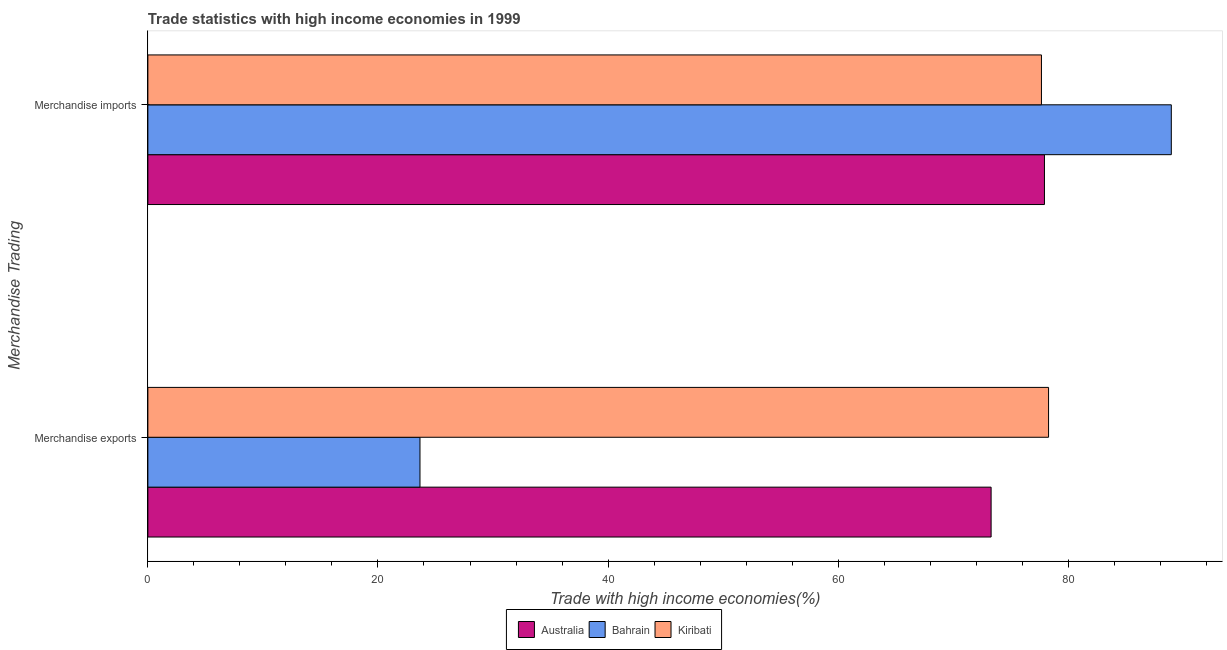How many different coloured bars are there?
Give a very brief answer. 3. Are the number of bars on each tick of the Y-axis equal?
Your response must be concise. Yes. How many bars are there on the 1st tick from the bottom?
Your answer should be very brief. 3. What is the merchandise exports in Kiribati?
Keep it short and to the point. 78.29. Across all countries, what is the maximum merchandise imports?
Ensure brevity in your answer.  88.96. Across all countries, what is the minimum merchandise exports?
Give a very brief answer. 23.65. In which country was the merchandise imports maximum?
Provide a succinct answer. Bahrain. In which country was the merchandise imports minimum?
Your answer should be compact. Kiribati. What is the total merchandise exports in the graph?
Keep it short and to the point. 175.24. What is the difference between the merchandise imports in Kiribati and that in Australia?
Your answer should be compact. -0.26. What is the difference between the merchandise exports in Kiribati and the merchandise imports in Australia?
Give a very brief answer. 0.36. What is the average merchandise exports per country?
Ensure brevity in your answer.  58.41. What is the difference between the merchandise imports and merchandise exports in Australia?
Your response must be concise. 4.64. In how many countries, is the merchandise exports greater than 84 %?
Make the answer very short. 0. What is the ratio of the merchandise imports in Bahrain to that in Kiribati?
Keep it short and to the point. 1.15. Is the merchandise exports in Kiribati less than that in Bahrain?
Your response must be concise. No. In how many countries, is the merchandise exports greater than the average merchandise exports taken over all countries?
Provide a short and direct response. 2. What does the 1st bar from the top in Merchandise exports represents?
Your response must be concise. Kiribati. How many bars are there?
Keep it short and to the point. 6. Are all the bars in the graph horizontal?
Give a very brief answer. Yes. Are the values on the major ticks of X-axis written in scientific E-notation?
Your answer should be very brief. No. Does the graph contain any zero values?
Provide a succinct answer. No. Does the graph contain grids?
Give a very brief answer. No. Where does the legend appear in the graph?
Your response must be concise. Bottom center. How many legend labels are there?
Provide a short and direct response. 3. How are the legend labels stacked?
Make the answer very short. Horizontal. What is the title of the graph?
Offer a very short reply. Trade statistics with high income economies in 1999. Does "Ecuador" appear as one of the legend labels in the graph?
Ensure brevity in your answer.  No. What is the label or title of the X-axis?
Your answer should be very brief. Trade with high income economies(%). What is the label or title of the Y-axis?
Ensure brevity in your answer.  Merchandise Trading. What is the Trade with high income economies(%) in Australia in Merchandise exports?
Your answer should be very brief. 73.29. What is the Trade with high income economies(%) of Bahrain in Merchandise exports?
Your response must be concise. 23.65. What is the Trade with high income economies(%) of Kiribati in Merchandise exports?
Give a very brief answer. 78.29. What is the Trade with high income economies(%) of Australia in Merchandise imports?
Make the answer very short. 77.93. What is the Trade with high income economies(%) in Bahrain in Merchandise imports?
Keep it short and to the point. 88.96. What is the Trade with high income economies(%) of Kiribati in Merchandise imports?
Provide a short and direct response. 77.67. Across all Merchandise Trading, what is the maximum Trade with high income economies(%) in Australia?
Provide a succinct answer. 77.93. Across all Merchandise Trading, what is the maximum Trade with high income economies(%) of Bahrain?
Give a very brief answer. 88.96. Across all Merchandise Trading, what is the maximum Trade with high income economies(%) in Kiribati?
Keep it short and to the point. 78.29. Across all Merchandise Trading, what is the minimum Trade with high income economies(%) of Australia?
Offer a terse response. 73.29. Across all Merchandise Trading, what is the minimum Trade with high income economies(%) in Bahrain?
Offer a very short reply. 23.65. Across all Merchandise Trading, what is the minimum Trade with high income economies(%) of Kiribati?
Provide a short and direct response. 77.67. What is the total Trade with high income economies(%) in Australia in the graph?
Ensure brevity in your answer.  151.23. What is the total Trade with high income economies(%) in Bahrain in the graph?
Your answer should be compact. 112.61. What is the total Trade with high income economies(%) of Kiribati in the graph?
Provide a short and direct response. 155.96. What is the difference between the Trade with high income economies(%) of Australia in Merchandise exports and that in Merchandise imports?
Give a very brief answer. -4.64. What is the difference between the Trade with high income economies(%) of Bahrain in Merchandise exports and that in Merchandise imports?
Offer a terse response. -65.31. What is the difference between the Trade with high income economies(%) of Kiribati in Merchandise exports and that in Merchandise imports?
Make the answer very short. 0.62. What is the difference between the Trade with high income economies(%) in Australia in Merchandise exports and the Trade with high income economies(%) in Bahrain in Merchandise imports?
Make the answer very short. -15.66. What is the difference between the Trade with high income economies(%) of Australia in Merchandise exports and the Trade with high income economies(%) of Kiribati in Merchandise imports?
Offer a very short reply. -4.38. What is the difference between the Trade with high income economies(%) in Bahrain in Merchandise exports and the Trade with high income economies(%) in Kiribati in Merchandise imports?
Offer a terse response. -54.02. What is the average Trade with high income economies(%) in Australia per Merchandise Trading?
Keep it short and to the point. 75.61. What is the average Trade with high income economies(%) of Bahrain per Merchandise Trading?
Provide a succinct answer. 56.31. What is the average Trade with high income economies(%) of Kiribati per Merchandise Trading?
Offer a very short reply. 77.98. What is the difference between the Trade with high income economies(%) of Australia and Trade with high income economies(%) of Bahrain in Merchandise exports?
Your answer should be compact. 49.64. What is the difference between the Trade with high income economies(%) in Australia and Trade with high income economies(%) in Kiribati in Merchandise exports?
Provide a short and direct response. -4.99. What is the difference between the Trade with high income economies(%) in Bahrain and Trade with high income economies(%) in Kiribati in Merchandise exports?
Ensure brevity in your answer.  -54.64. What is the difference between the Trade with high income economies(%) in Australia and Trade with high income economies(%) in Bahrain in Merchandise imports?
Give a very brief answer. -11.03. What is the difference between the Trade with high income economies(%) in Australia and Trade with high income economies(%) in Kiribati in Merchandise imports?
Your answer should be very brief. 0.26. What is the difference between the Trade with high income economies(%) in Bahrain and Trade with high income economies(%) in Kiribati in Merchandise imports?
Provide a short and direct response. 11.29. What is the ratio of the Trade with high income economies(%) in Australia in Merchandise exports to that in Merchandise imports?
Keep it short and to the point. 0.94. What is the ratio of the Trade with high income economies(%) in Bahrain in Merchandise exports to that in Merchandise imports?
Keep it short and to the point. 0.27. What is the difference between the highest and the second highest Trade with high income economies(%) in Australia?
Offer a very short reply. 4.64. What is the difference between the highest and the second highest Trade with high income economies(%) of Bahrain?
Ensure brevity in your answer.  65.31. What is the difference between the highest and the second highest Trade with high income economies(%) in Kiribati?
Offer a terse response. 0.62. What is the difference between the highest and the lowest Trade with high income economies(%) in Australia?
Make the answer very short. 4.64. What is the difference between the highest and the lowest Trade with high income economies(%) of Bahrain?
Offer a very short reply. 65.31. What is the difference between the highest and the lowest Trade with high income economies(%) in Kiribati?
Offer a terse response. 0.62. 